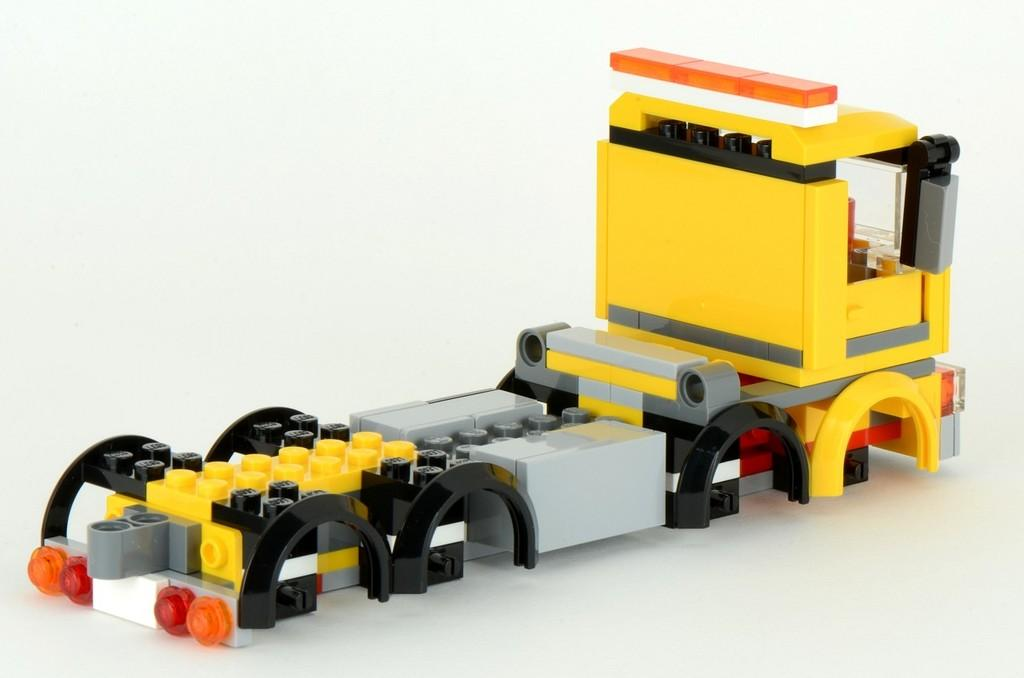What type of toy is present in the image? There is a toy truck in the image. What material is the toy truck made of? The toy truck is made of legos. How much money is being exchanged in the image? There is no money being exchanged in the image; it features a toy truck made of legos. Is there a tent visible in the image? No, there is no tent present in the image. 